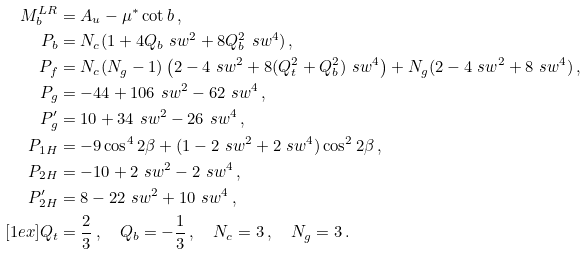<formula> <loc_0><loc_0><loc_500><loc_500>M _ { b } ^ { L R } & = A _ { u } - \mu ^ { * } \cot b \, , \\ P _ { b } & = N _ { c } ( 1 + 4 Q _ { b } \ s w ^ { 2 } + 8 Q _ { b } ^ { 2 } \ s w ^ { 4 } ) \, , \\ P _ { f } & = N _ { c } ( N _ { g } - 1 ) \left ( 2 - 4 \ s w ^ { 2 } + 8 ( Q _ { t } ^ { 2 } + Q _ { b } ^ { 2 } ) \ s w ^ { 4 } \right ) + N _ { g } ( 2 - 4 \ s w ^ { 2 } + 8 \ s w ^ { 4 } ) \, , \\ P _ { g } & = - 4 4 + 1 0 6 \ s w ^ { 2 } - 6 2 \ s w ^ { 4 } \, , \\ P ^ { \prime } _ { g } & = 1 0 + 3 4 \ s w ^ { 2 } - 2 6 \ s w ^ { 4 } \, , \\ P _ { 1 H } & = - 9 \cos ^ { 4 } 2 \beta + ( 1 - 2 \ s w ^ { 2 } + 2 \ s w ^ { 4 } ) \cos ^ { 2 } 2 \beta \, , \\ P _ { 2 H } & = - 1 0 + 2 \ s w ^ { 2 } - 2 \ s w ^ { 4 } \, , \\ P ^ { \prime } _ { 2 H } & = 8 - 2 2 \ s w ^ { 2 } + 1 0 \ s w ^ { 4 } \, , \\ [ 1 e x ] Q _ { t } & = \frac { 2 } { 3 } \, , \quad Q _ { b } = - \frac { 1 } { 3 } \, , \quad N _ { c } = 3 \, , \quad N _ { g } = 3 \, .</formula> 